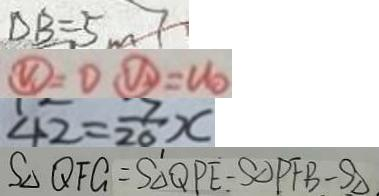<formula> <loc_0><loc_0><loc_500><loc_500>D B = 5 m 7 
 \textcircled { V _ { 1 } } = 0 \textcircled { V _ { 2 } } = U _ { 0 } 
 4 2 = \frac { 7 } { 2 0 } x 
 S _ { \Delta } Q F G - S _ { \Delta } Q P E - S _ { \Delta } P F B - S _ { \Delta }</formula> 